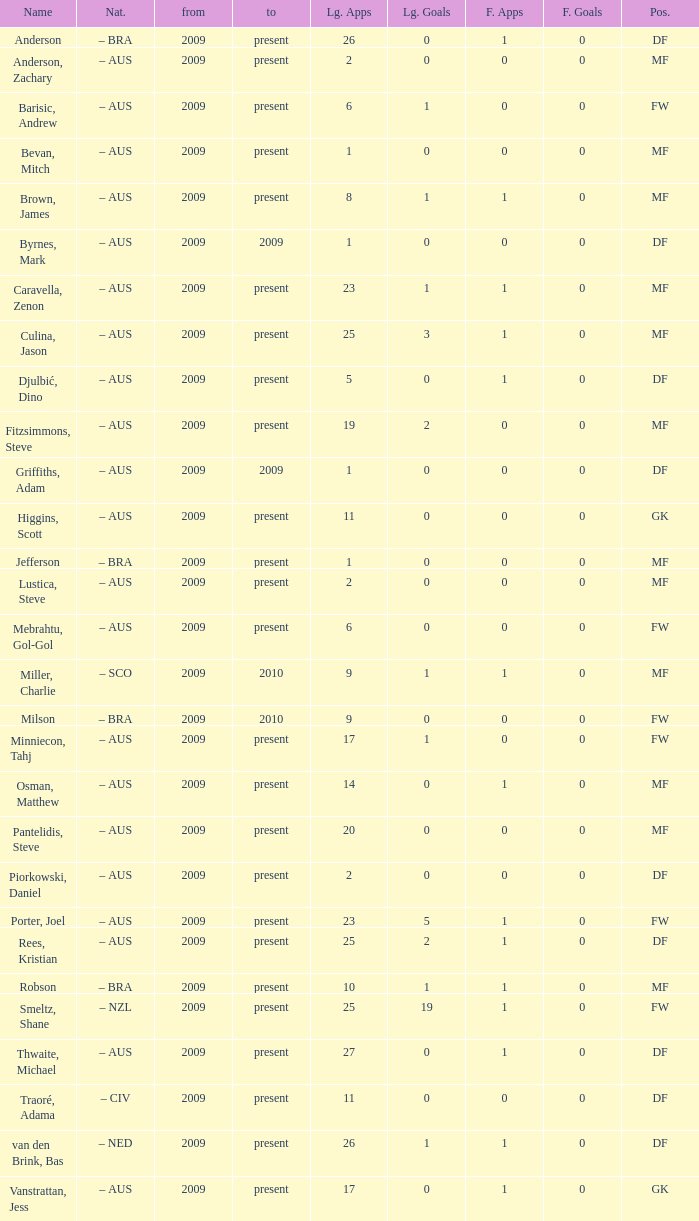Name the to for 19 league apps Present. 